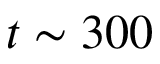<formula> <loc_0><loc_0><loc_500><loc_500>t \sim 3 0 0</formula> 